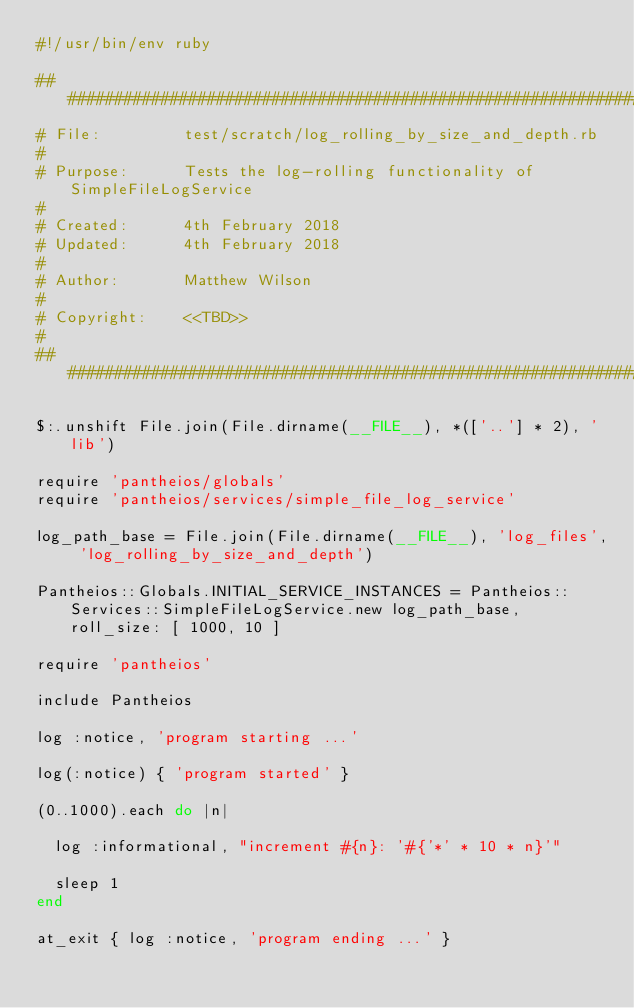Convert code to text. <code><loc_0><loc_0><loc_500><loc_500><_Ruby_>#!/usr/bin/env ruby

#############################################################################
# File:         test/scratch/log_rolling_by_size_and_depth.rb
#
# Purpose:      Tests the log-rolling functionality of SimpleFileLogService
#
# Created:      4th February 2018
# Updated:      4th February 2018
#
# Author:       Matthew Wilson
#
# Copyright:    <<TBD>>
#
#############################################################################

$:.unshift File.join(File.dirname(__FILE__), *(['..'] * 2), 'lib')

require 'pantheios/globals'
require 'pantheios/services/simple_file_log_service'

log_path_base = File.join(File.dirname(__FILE__), 'log_files', 'log_rolling_by_size_and_depth')

Pantheios::Globals.INITIAL_SERVICE_INSTANCES = Pantheios::Services::SimpleFileLogService.new log_path_base, roll_size: [ 1000, 10 ]

require 'pantheios'

include Pantheios

log :notice, 'program starting ...'

log(:notice) { 'program started' }

(0..1000).each do |n|

	log :informational, "increment #{n}: '#{'*' * 10 * n}'"

	sleep 1
end

at_exit { log :notice, 'program ending ...' }


</code> 